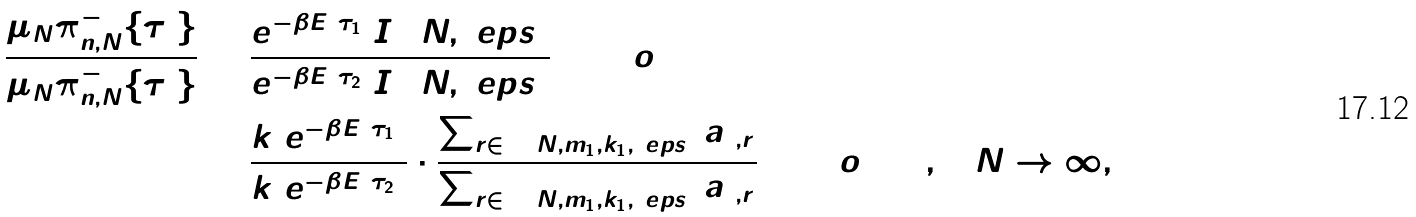<formula> <loc_0><loc_0><loc_500><loc_500>\frac { \mu _ { N } \pi _ { n , N } ^ { - 1 } \{ \tau _ { 1 } \} } { \mu _ { N } \pi _ { n , N } ^ { - 1 } \{ \tau _ { 2 } \} } & = \frac { e ^ { - \beta \bar { E } ( \tau _ { 1 } ) } I _ { 1 } ( N , \ e p s ) } { e ^ { - \beta \bar { E } ( \tau _ { 2 } ) } I _ { 2 } ( N , \ e p s ) } ( 1 + o ( 1 ) ) \\ & = \frac { k _ { 1 } e ^ { - \beta \bar { E } ( \tau _ { 1 } ) } } { k _ { 2 } e ^ { - \beta \bar { E } ( \tau _ { 2 } ) } } \cdot \frac { \sum _ { r \in \Delta ( N , m _ { 1 } , k _ { 1 } , \ e p s ) } a _ { 1 , r } } { \sum _ { r \in \Delta ( N , m _ { 1 } , k _ { 1 } , \ e p s ) } a _ { 2 , r } } ( 1 + o ( 1 ) ) , \quad N \to \infty ,</formula> 